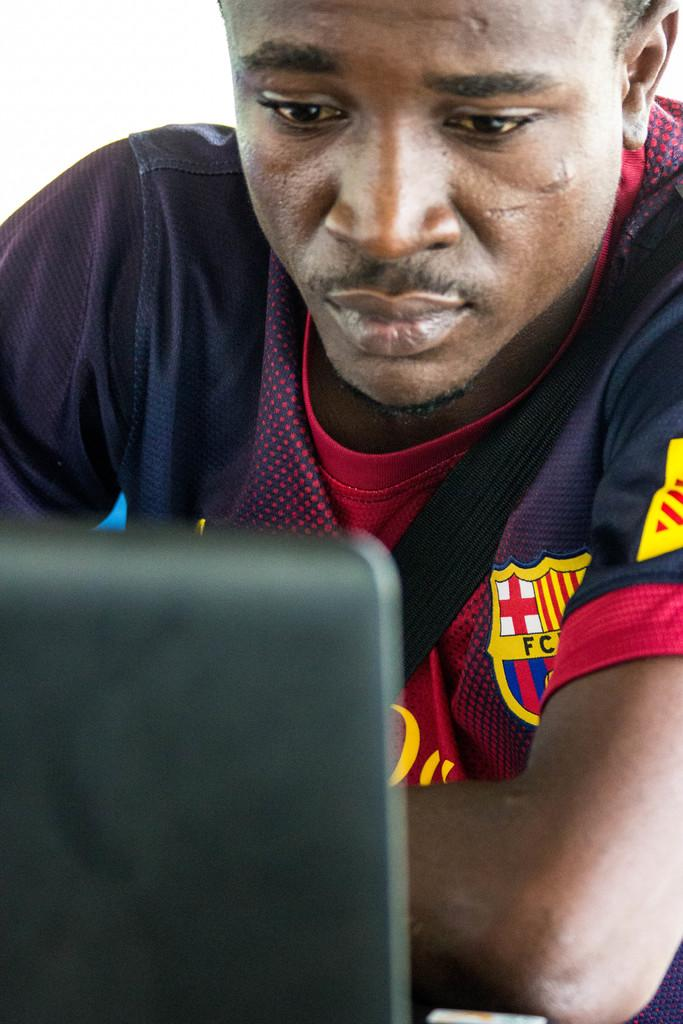<image>
Present a compact description of the photo's key features. A man is wearing a shirt with a crest containing the letters FC. 